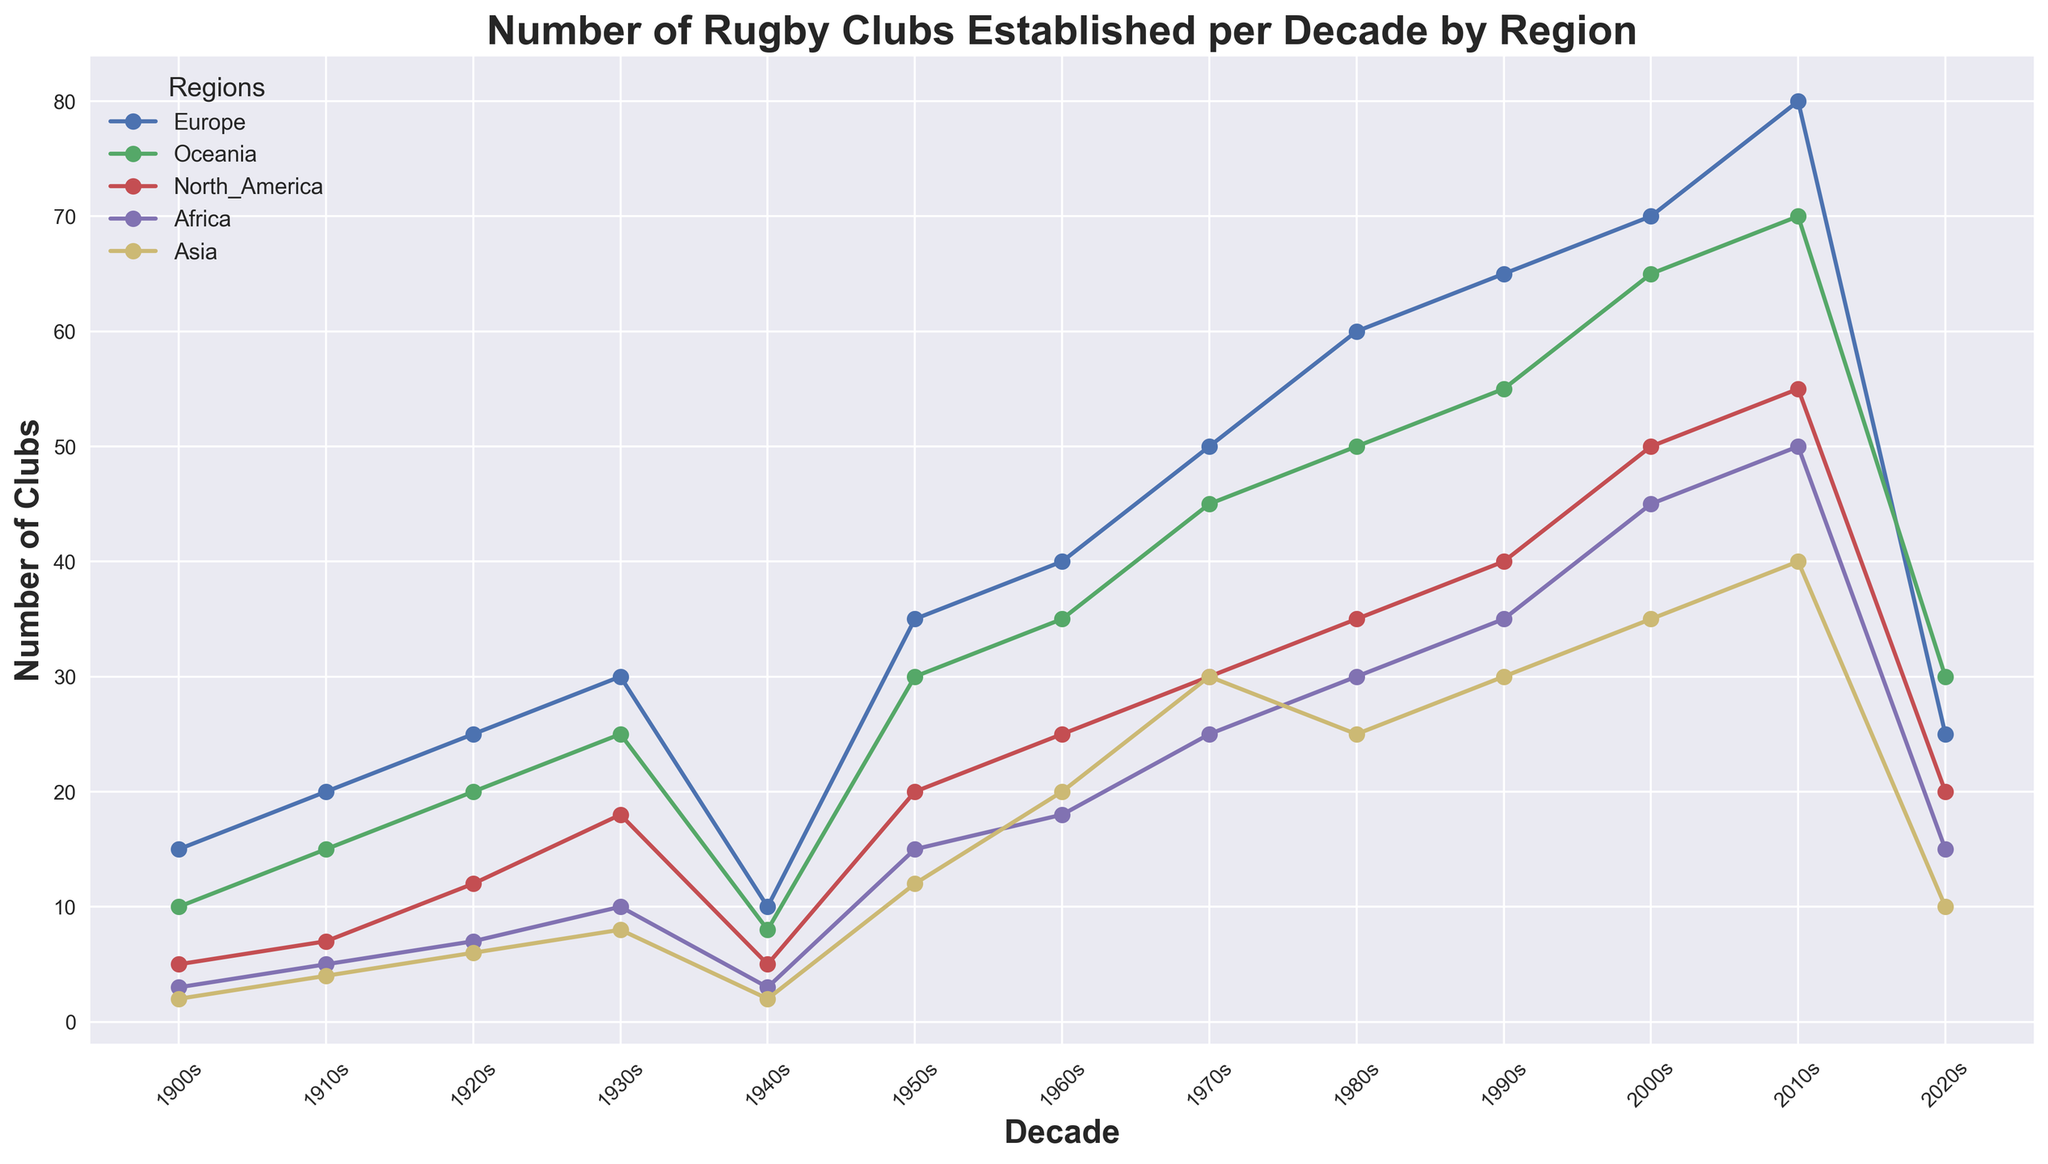What trend can be seen in the number of rugby clubs established in Europe from the 1900s to the 1970s? From the 1900s to the 1970s, the number of rugby clubs in Europe increased steadily almost every decade. Starting at 15 in the 1900s and rising to 50 in the 1970s.
Answer: Steady increase Which region had the highest number of clubs established in the 2010s? Looking at the 2010s data, Europe had 80 clubs, Oceania had 70, North America had 55, Africa had 50, and Asia had 40. Europe had the highest number of clubs established.
Answer: Europe How does the number of rugby clubs in Africa in the 2020s compare to that in Asia in the same period? In the 2020s, Africa had 15 clubs while Asia had 10 clubs. Africa had more clubs established than Asia in the 2020s.
Answer: Africa had more What decade saw the sharpest increase in the number of clubs in Oceania? By observing the plot, the highest increase in the number of clubs for Oceania occurred from the 1940s to the 1950s, where the number increased from 8 to 30 clubs (+22).
Answer: 1950s Which two regions had the closest number of clubs established in the 1980s? In the 1980s: Europe had 60 clubs, Oceania had 50, North America had 35, Africa had 30, and Asia had 25. Africa and North America had the closest numbers with 30 and 35 clubs respectively, a difference of 5.
Answer: Africa and North America What is the average number of clubs established in Europe between 2000s and 2020s? The number of clubs in Europe in the 2000s was 70, in the 2010s was 80, and in the 2020s was 25. The average is calculated as (70+80+25)/3 = 58.33.
Answer: 58.33 In which decade did the number of rugby clubs in North America first exceed 30? Observing the plot, in North America, the number of clubs first exceeded 30 when it reached 35 in the 1980s.
Answer: 1980s How did the number of rugby clubs in Africa change from the 1970s to the 1980s? In the 1970s, Africa had 25 clubs, and in the 1980s, it had 30 clubs. So the number of clubs increased by 5.
Answer: Increased by 5 Comparing the 1940s, which region had the smallest number of clubs? In the 1940s: Europe had 10 clubs, Oceania had 8, North America had 5, Africa had 3, and Asia had 2 clubs. Asia had the smallest number of clubs.
Answer: Asia If the trends continued, which region is likely to see a decrease in the number of clubs established in the next decade based on their 2020s data? Observing the plot, the regions with the decreasing or lower number of clubs in the 2020s are Europe (25), Oceania (30), North America (20), Africa (15), and Asia (10). Given the declining trend in the last few decades, Europe is likely to see a decrease.
Answer: Europe 